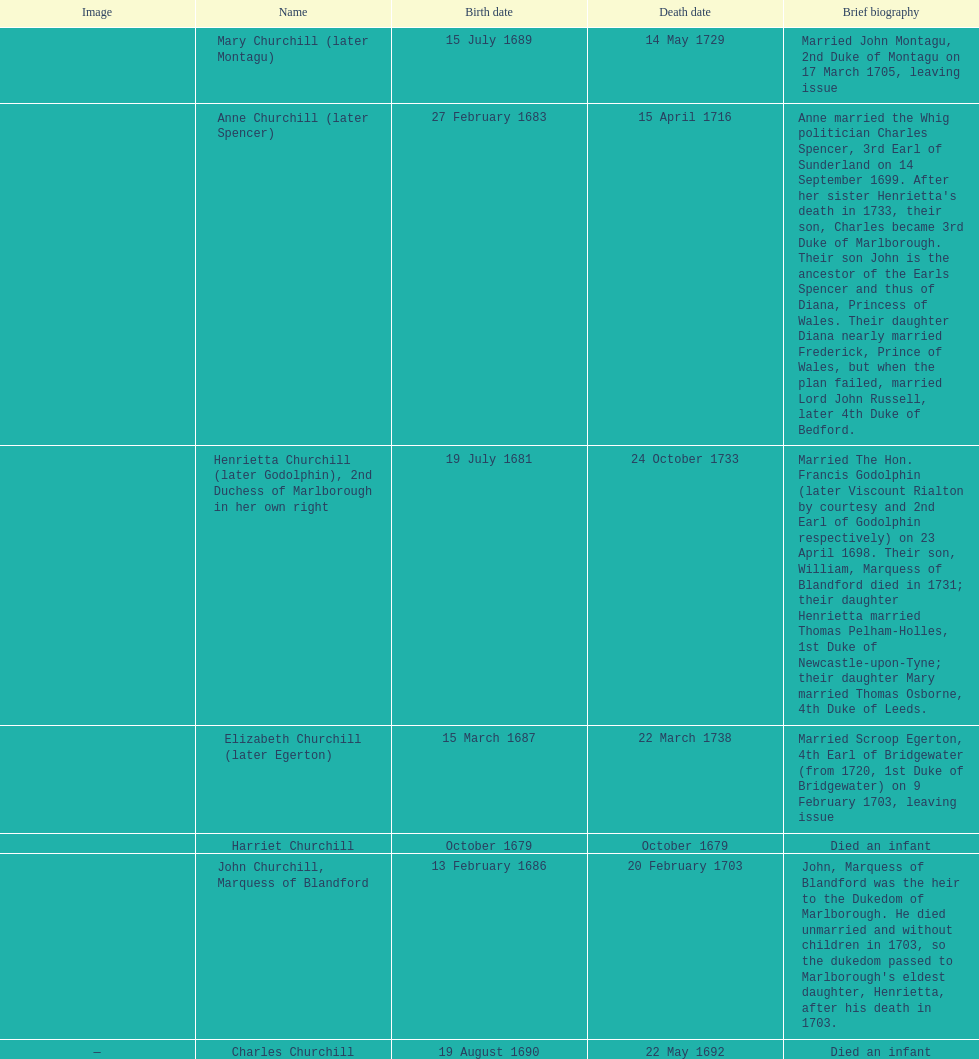Who was born before henrietta churchhill? Harriet Churchill. 